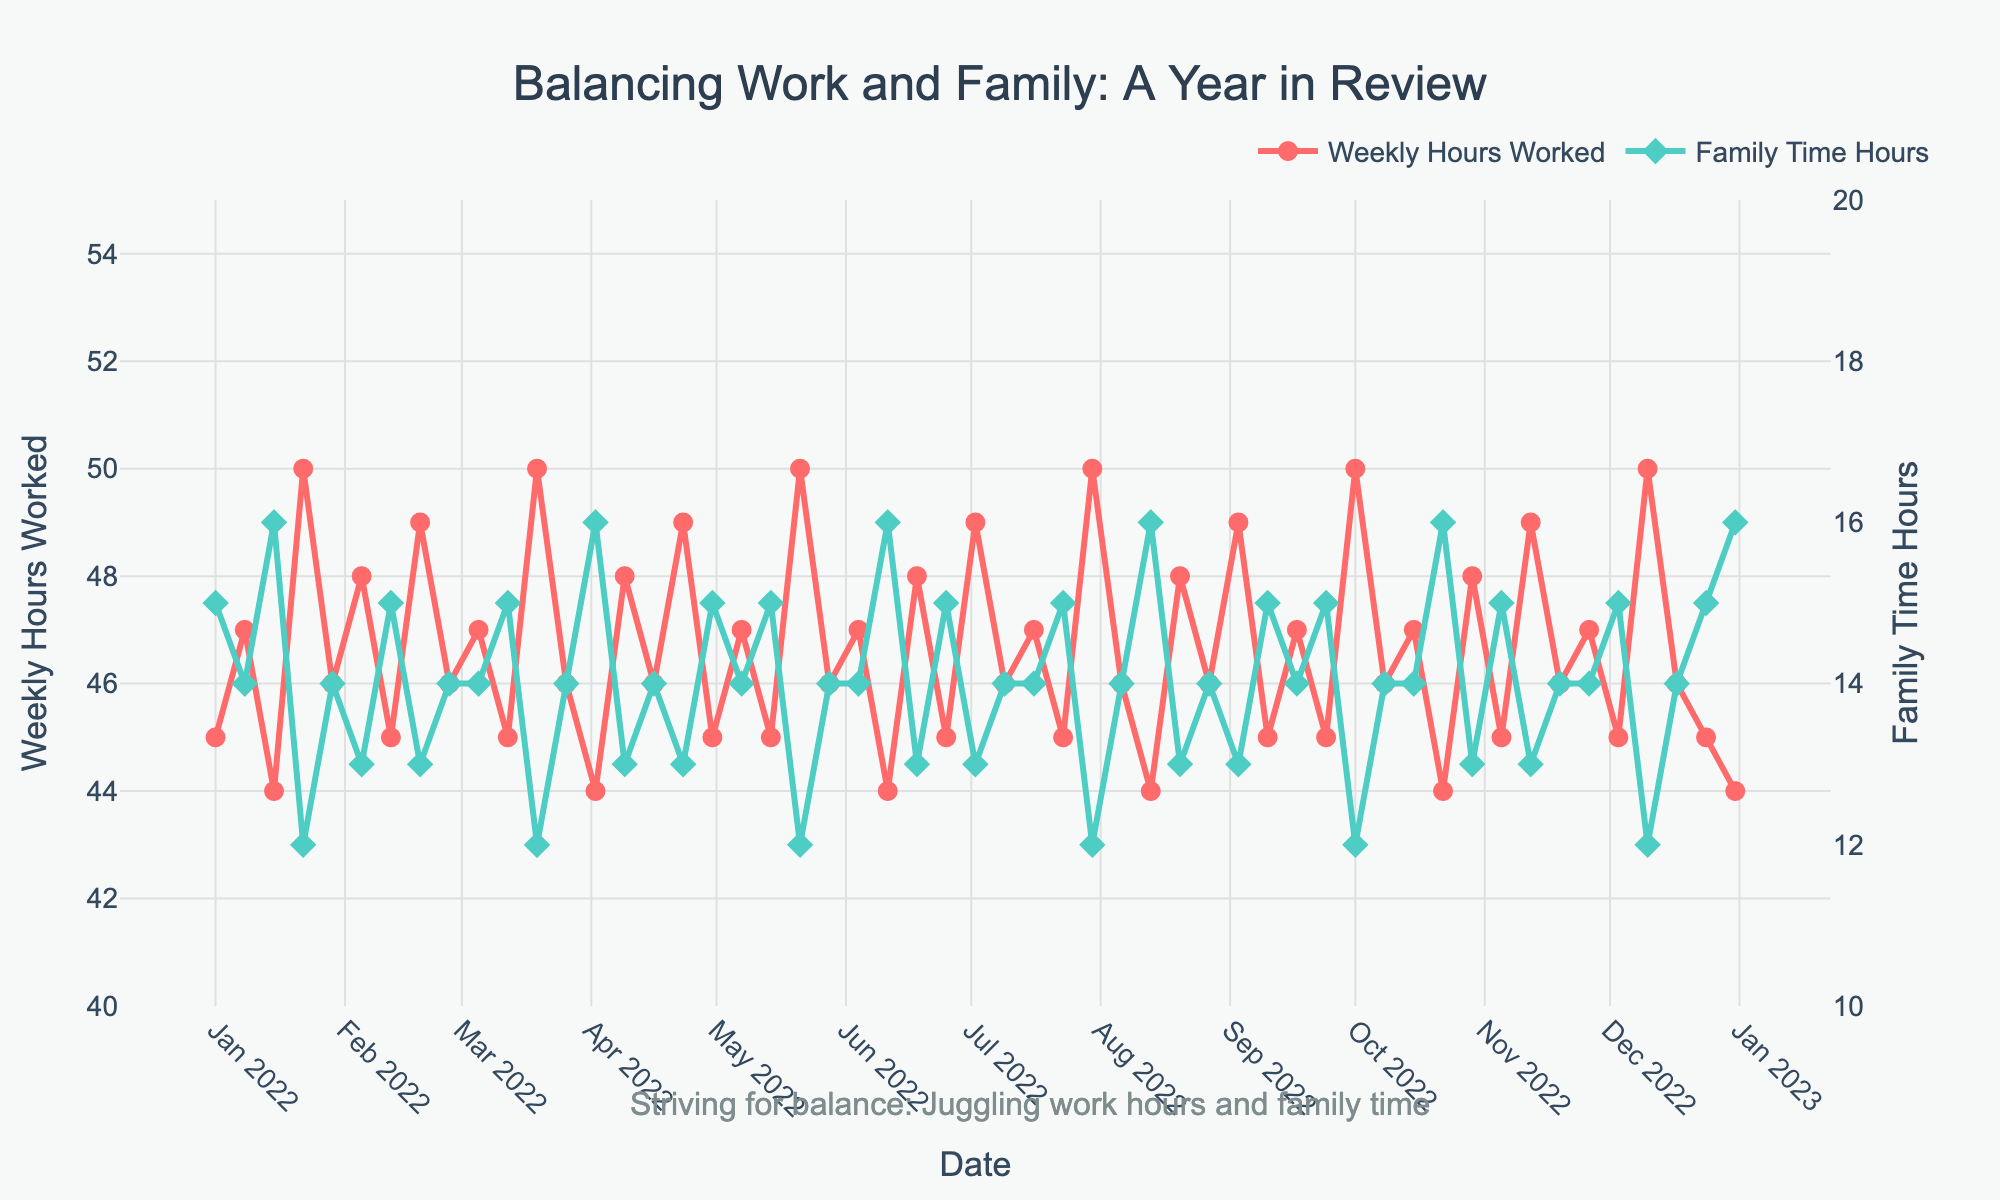What is the title of the figure? The title is located at the top center of the figure. It reads "Balancing Work and Family: A Year in Review".
Answer: Balancing Work and Family: A Year in Review What are the y-axes representing? The left y-axis represents "Weekly Hours Worked", indicated with a red line, and the right y-axis represents "Family Time Hours", indicated with a green line.
Answer: Weekly Hours Worked, Family Time Hours When was the highest "Weekly Hours Worked" recorded, and what was the value? The highest "Weekly Hours Worked" is marked at multiple points in time, with the peak visible at several dates, including 2022-01-22, 2022-03-19, 2022-05-21, 2022-07-30, 2022-10-01, and 2022-12-10. The value is 50 hours.
Answer: 2022-01-22, 50 hours What is the general trend of "Family Time Hours" over the year? Examining the green line that marks "Family Time Hours", it fluctuates between 12 and 16 hours throughout the year, without a clear increasing or decreasing trend.
Answer: Fluctuates between 12 and 16 hours Which month had both the highest "Weekly Hours Worked" and the lowest "Family Time Hours"? The highest "Weekly Hours Worked" and lowest "Family Time Hours" coincide in several months. For example, in July, October, and December, the working hours peaked at 50 hours per week, and family time dropped to around 12 hours.
Answer: July, October, December How many times did "Weekly Hours Worked" reach 50 hours over the past year? Looking closely at the red line, it hits the 50-hour mark several times. These peaks are observed approximately 6 times throughout the year.
Answer: 6 times Is there any visible correlation between "Weekly Hours Worked" and "Family Time Hours"? The figure shows an inverse relationship: as "Weekly Hours Worked" increases (red line), "Family Time Hours" (green line) decreases, indicating less family time when more hours are worked.
Answer: Inverse relationship What is the maximum value of "Family Time Hours" and when was it recorded? The maximum "Family Time Hours" recorded is 16 hours, observed on several dates such as 2022-01-15, 2022-04-02, 2022-06-11, 2022-08-13, 2022-10-22, and 2022-12-31.
Answer: 16 hours, 2022-01-15 How do "Family Time Hours" change right after a week of 50 "Weekly Hours Worked"? Examining weeks right after the multiple peaks of 50 "Weekly Hours Worked", the "Family Time Hours" generally increase back to the 13-16 hours range the following week.
Answer: Increase to 13-16 hours 